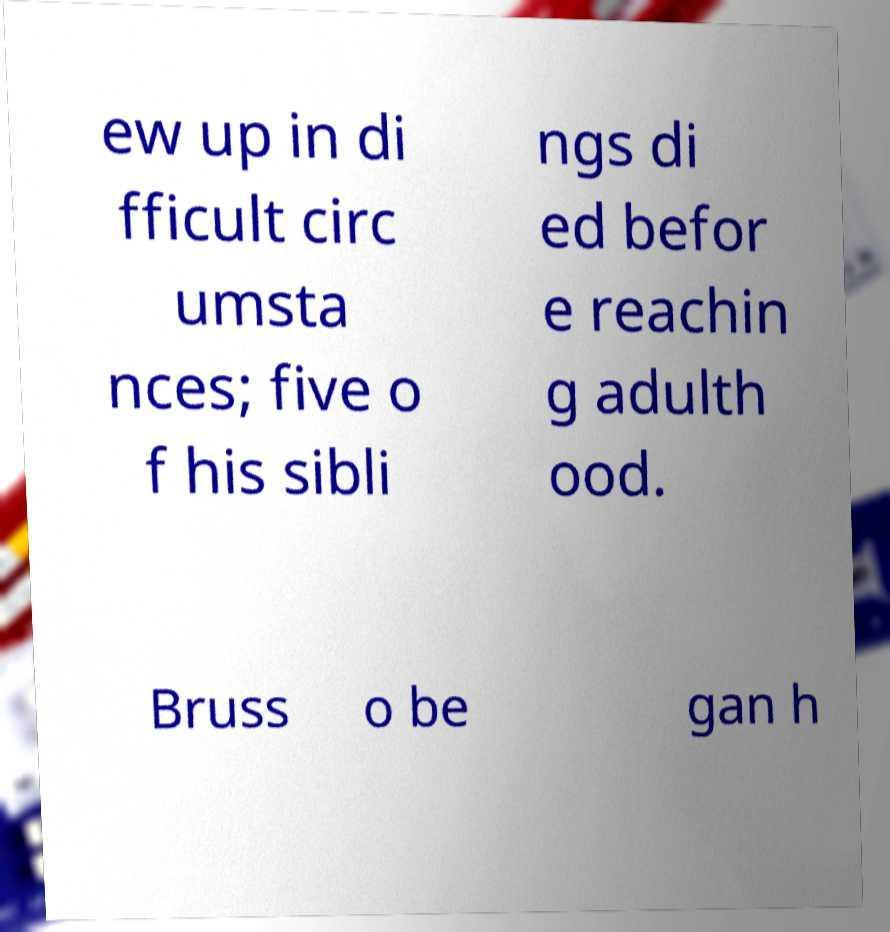What messages or text are displayed in this image? I need them in a readable, typed format. ew up in di fficult circ umsta nces; five o f his sibli ngs di ed befor e reachin g adulth ood. Bruss o be gan h 